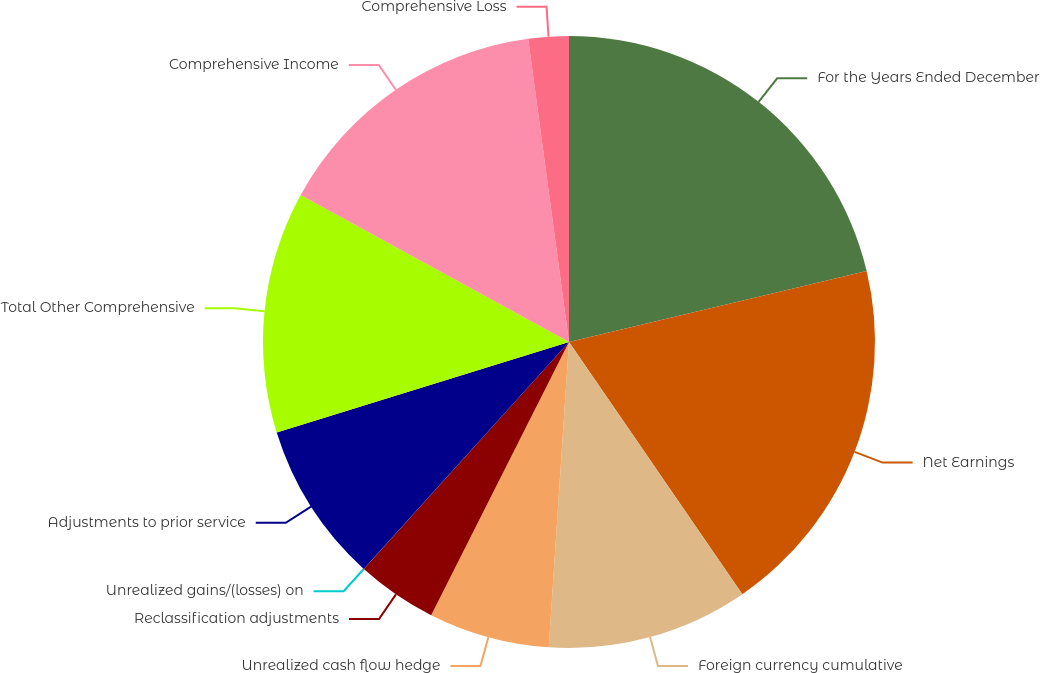<chart> <loc_0><loc_0><loc_500><loc_500><pie_chart><fcel>For the Years Ended December<fcel>Net Earnings<fcel>Foreign currency cumulative<fcel>Unrealized cash flow hedge<fcel>Reclassification adjustments<fcel>Unrealized gains/(losses) on<fcel>Adjustments to prior service<fcel>Total Other Comprehensive<fcel>Comprehensive Income<fcel>Comprehensive Loss<nl><fcel>21.27%<fcel>19.14%<fcel>10.64%<fcel>6.38%<fcel>4.26%<fcel>0.01%<fcel>8.51%<fcel>12.76%<fcel>14.89%<fcel>2.13%<nl></chart> 